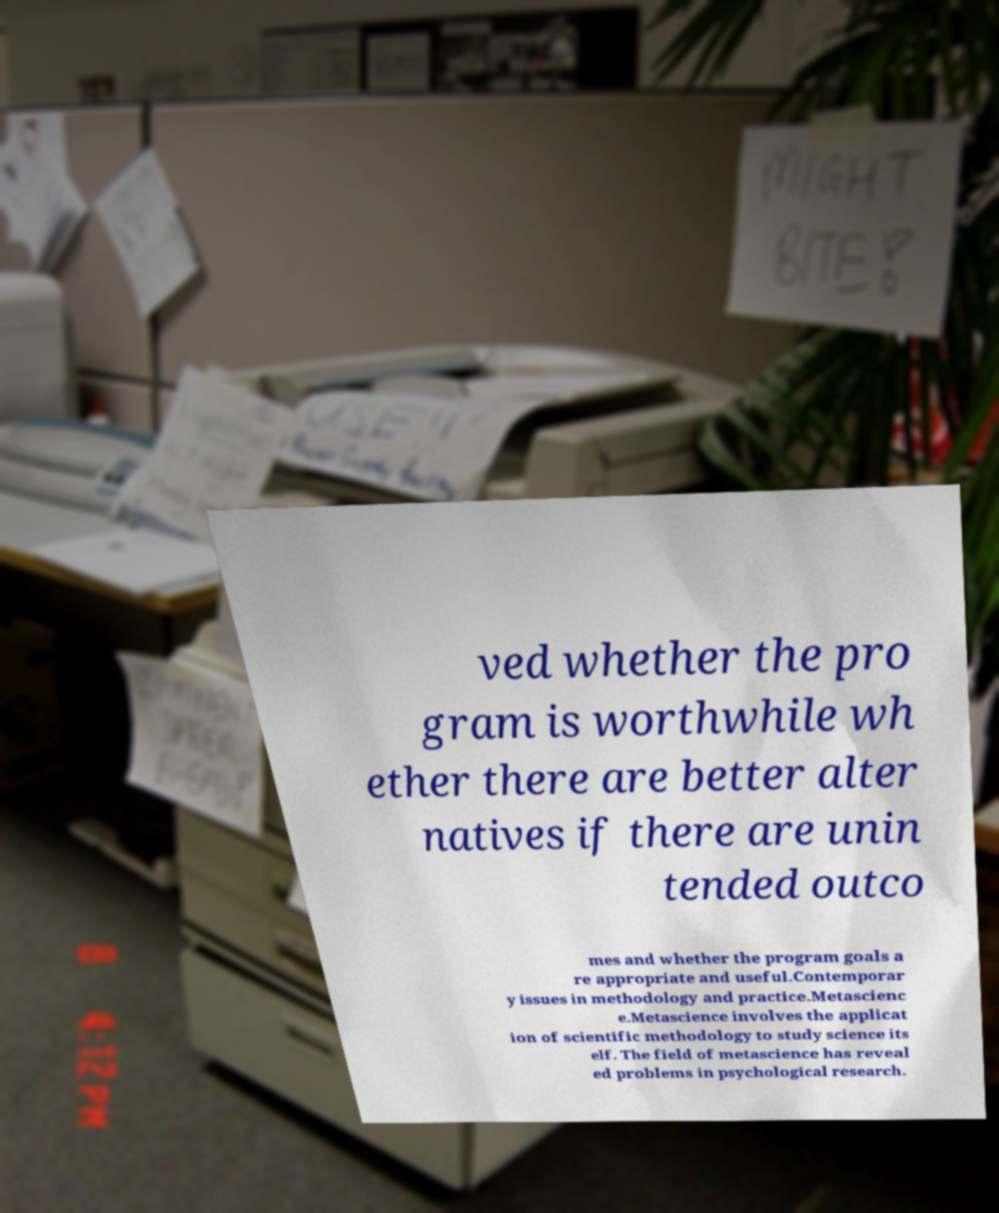There's text embedded in this image that I need extracted. Can you transcribe it verbatim? ved whether the pro gram is worthwhile wh ether there are better alter natives if there are unin tended outco mes and whether the program goals a re appropriate and useful.Contemporar y issues in methodology and practice.Metascienc e.Metascience involves the applicat ion of scientific methodology to study science its elf. The field of metascience has reveal ed problems in psychological research. 